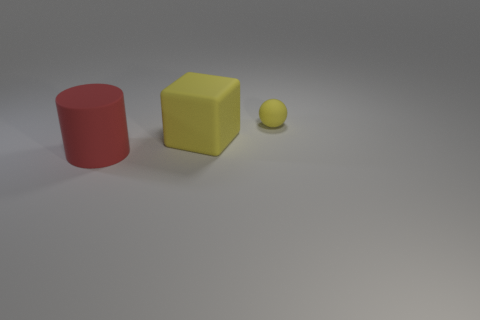What is the color of the object to the left of the large rubber object that is behind the red rubber thing?
Provide a short and direct response. Red. Is the number of rubber things that are to the left of the matte block greater than the number of matte objects on the left side of the small yellow rubber thing?
Keep it short and to the point. No. Are there any matte objects to the left of the small matte ball?
Give a very brief answer. Yes. What number of cyan things are big cylinders or balls?
Provide a succinct answer. 0. Are the cylinder and the object behind the large yellow matte object made of the same material?
Your answer should be compact. Yes. Is the size of the yellow object that is on the left side of the ball the same as the matte thing on the right side of the large matte cube?
Provide a short and direct response. No. What number of other objects are the same material as the red thing?
Offer a very short reply. 2. What number of rubber things are either big yellow objects or large red objects?
Make the answer very short. 2. Are there fewer cylinders than rubber things?
Provide a short and direct response. Yes. Is the size of the ball the same as the rubber thing in front of the yellow matte cube?
Offer a very short reply. No. 